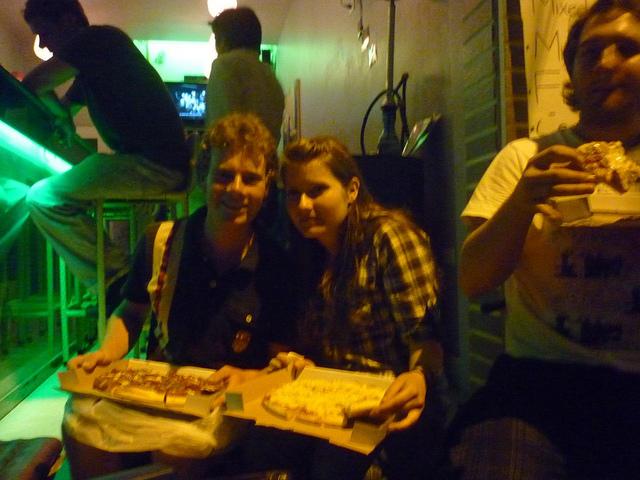How many people are in the photo?
Keep it brief. 5. Is there pizza in this picture?
Answer briefly. Yes. Which man holds food in his right hand?
Concise answer only. Far right. 